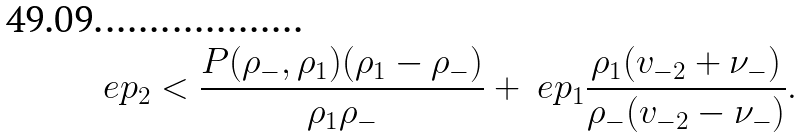<formula> <loc_0><loc_0><loc_500><loc_500>\ e p _ { 2 } < \frac { P ( \rho _ { - } , \rho _ { 1 } ) ( \rho _ { 1 } - \rho _ { - } ) } { \rho _ { 1 } \rho _ { - } } + \ e p _ { 1 } \frac { \rho _ { 1 } ( v _ { - 2 } + \nu _ { - } ) } { \rho _ { - } ( v _ { - 2 } - \nu _ { - } ) } .</formula> 